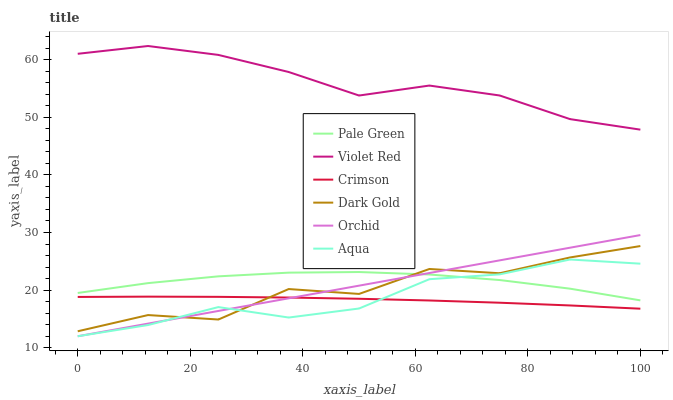Does Crimson have the minimum area under the curve?
Answer yes or no. Yes. Does Violet Red have the maximum area under the curve?
Answer yes or no. Yes. Does Dark Gold have the minimum area under the curve?
Answer yes or no. No. Does Dark Gold have the maximum area under the curve?
Answer yes or no. No. Is Orchid the smoothest?
Answer yes or no. Yes. Is Dark Gold the roughest?
Answer yes or no. Yes. Is Aqua the smoothest?
Answer yes or no. No. Is Aqua the roughest?
Answer yes or no. No. Does Aqua have the lowest value?
Answer yes or no. Yes. Does Dark Gold have the lowest value?
Answer yes or no. No. Does Violet Red have the highest value?
Answer yes or no. Yes. Does Dark Gold have the highest value?
Answer yes or no. No. Is Dark Gold less than Violet Red?
Answer yes or no. Yes. Is Violet Red greater than Dark Gold?
Answer yes or no. Yes. Does Aqua intersect Orchid?
Answer yes or no. Yes. Is Aqua less than Orchid?
Answer yes or no. No. Is Aqua greater than Orchid?
Answer yes or no. No. Does Dark Gold intersect Violet Red?
Answer yes or no. No. 